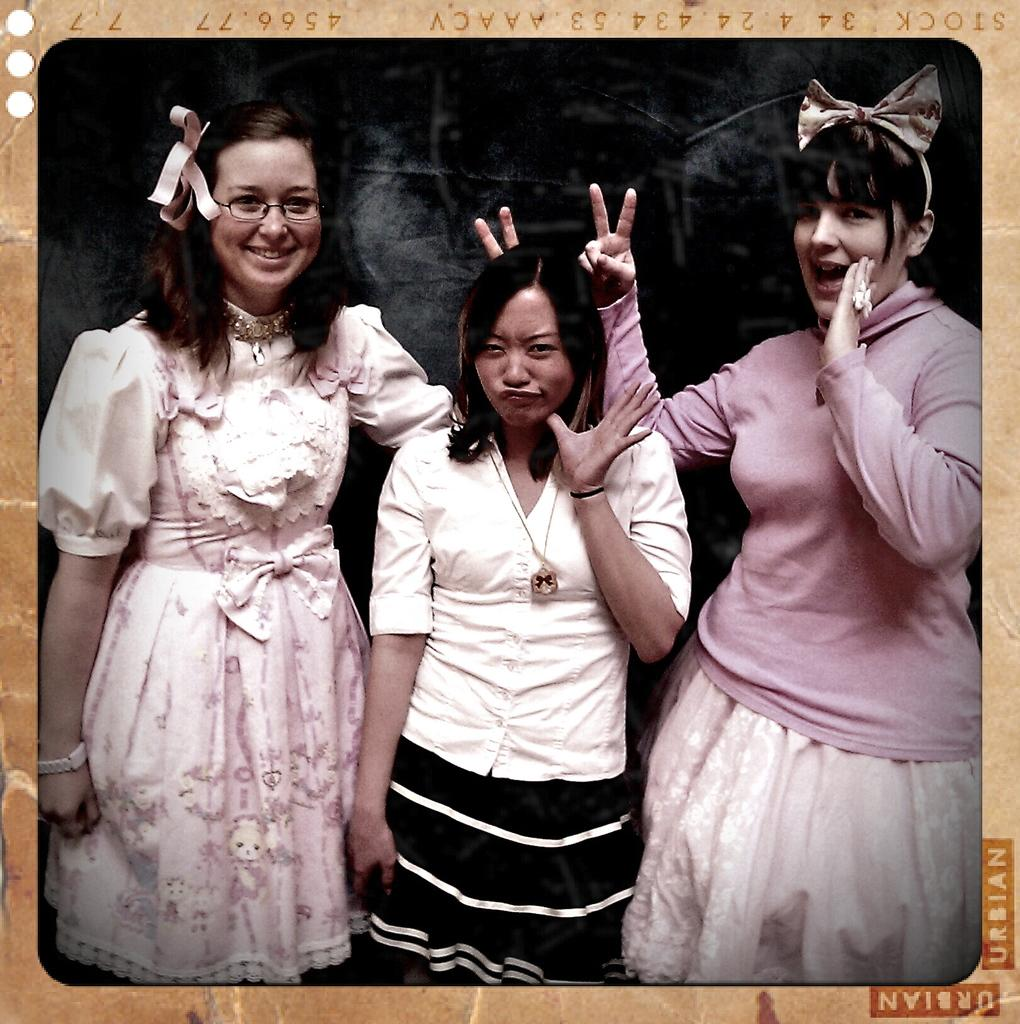What is the main subject of the image? The main subject of the image is a photograph. How many people are in the photograph? There are three persons standing in the photograph. Can you describe the additional element at the right bottom of the image? It could be a part of the photograph or another element, but it is not clear from the provided facts. What type of pizzas are the family members eating in the image? There is no reference to pizzas or a family in the image, so it is not possible to answer that question. 